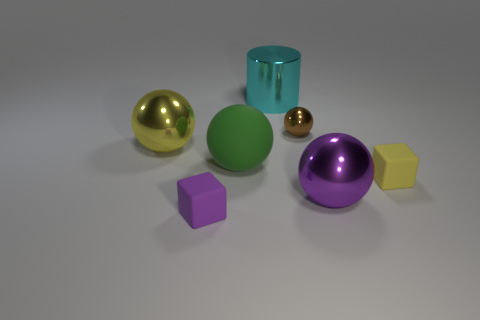Subtract all green spheres. How many spheres are left? 3 Subtract all brown spheres. How many spheres are left? 3 Subtract 2 cubes. How many cubes are left? 0 Add 1 rubber blocks. How many objects exist? 8 Subtract all blocks. How many objects are left? 5 Subtract all gray spheres. Subtract all yellow blocks. How many spheres are left? 4 Subtract all large rubber cylinders. Subtract all tiny yellow rubber cubes. How many objects are left? 6 Add 2 tiny purple cubes. How many tiny purple cubes are left? 3 Add 6 small purple matte blocks. How many small purple matte blocks exist? 7 Subtract 1 purple balls. How many objects are left? 6 